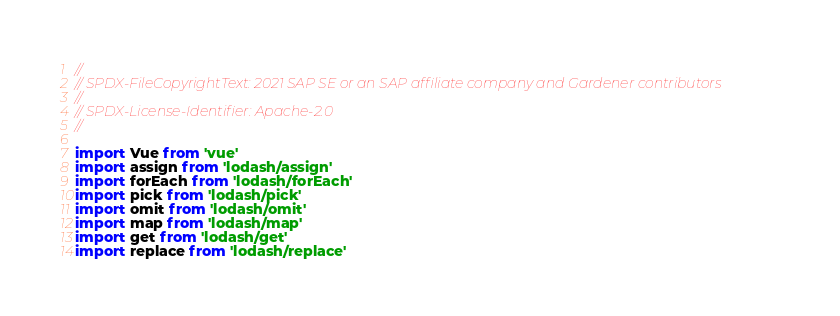Convert code to text. <code><loc_0><loc_0><loc_500><loc_500><_JavaScript_>//
// SPDX-FileCopyrightText: 2021 SAP SE or an SAP affiliate company and Gardener contributors
//
// SPDX-License-Identifier: Apache-2.0
//

import Vue from 'vue'
import assign from 'lodash/assign'
import forEach from 'lodash/forEach'
import pick from 'lodash/pick'
import omit from 'lodash/omit'
import map from 'lodash/map'
import get from 'lodash/get'
import replace from 'lodash/replace'</code> 